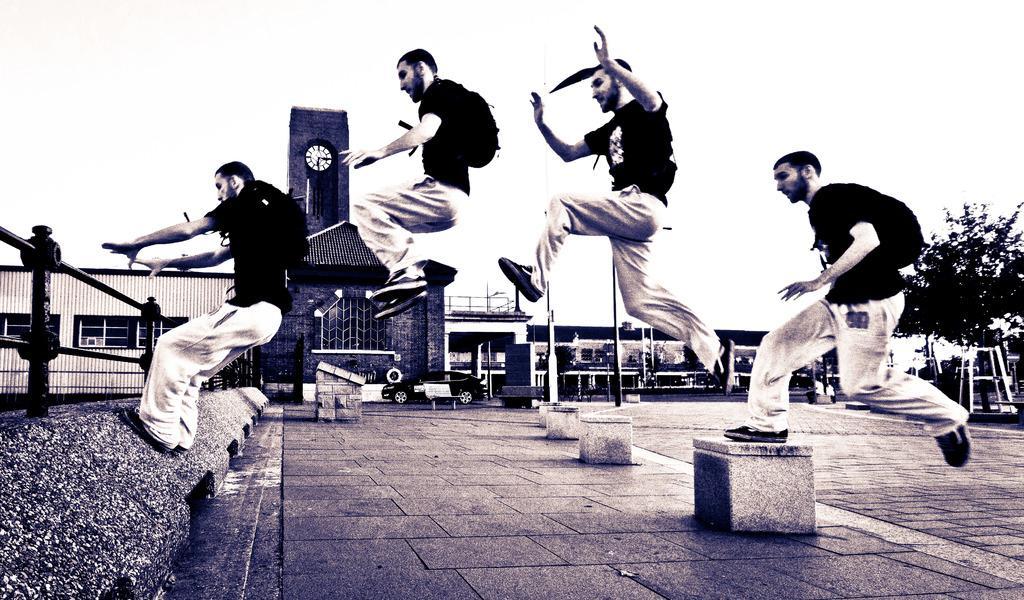Describe this image in one or two sentences. In this image we can see a person jumping. There is a barrier in the image. There are few poles in the image. There are few buildings in the image. There is a clock on the wall. We can see the sky in the image. There is a vehicle in the image. There is a tree at the right side of the image. 